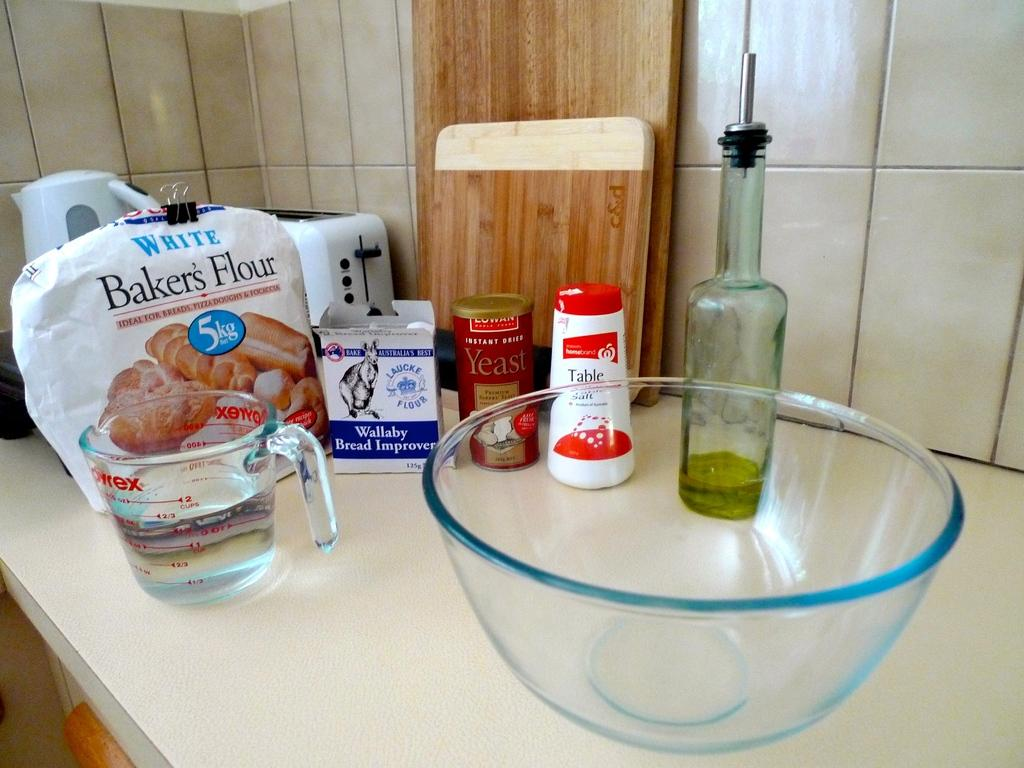<image>
Provide a brief description of the given image. A mixing bowl is on a counter with bakers flour and Wallaby bread improver. 